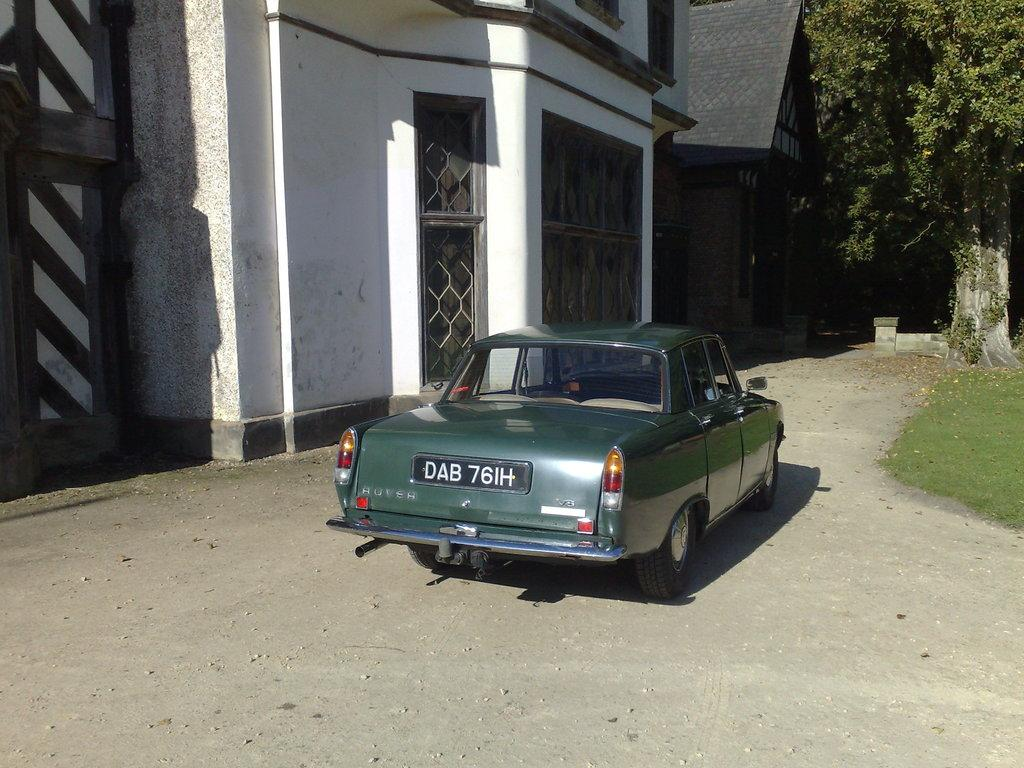What color is the car in the image? The car in the image is green. Where is the car located in the image? The car is on the ground. What can be seen in the background of the image? There are buildings, trees, and grass visible in the background of the image. Can you see a deer standing next to the car in the image? No, there is no deer present in the image. 